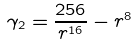Convert formula to latex. <formula><loc_0><loc_0><loc_500><loc_500>\gamma _ { 2 } = \frac { 2 5 6 } { r ^ { 1 6 } } - r ^ { 8 }</formula> 